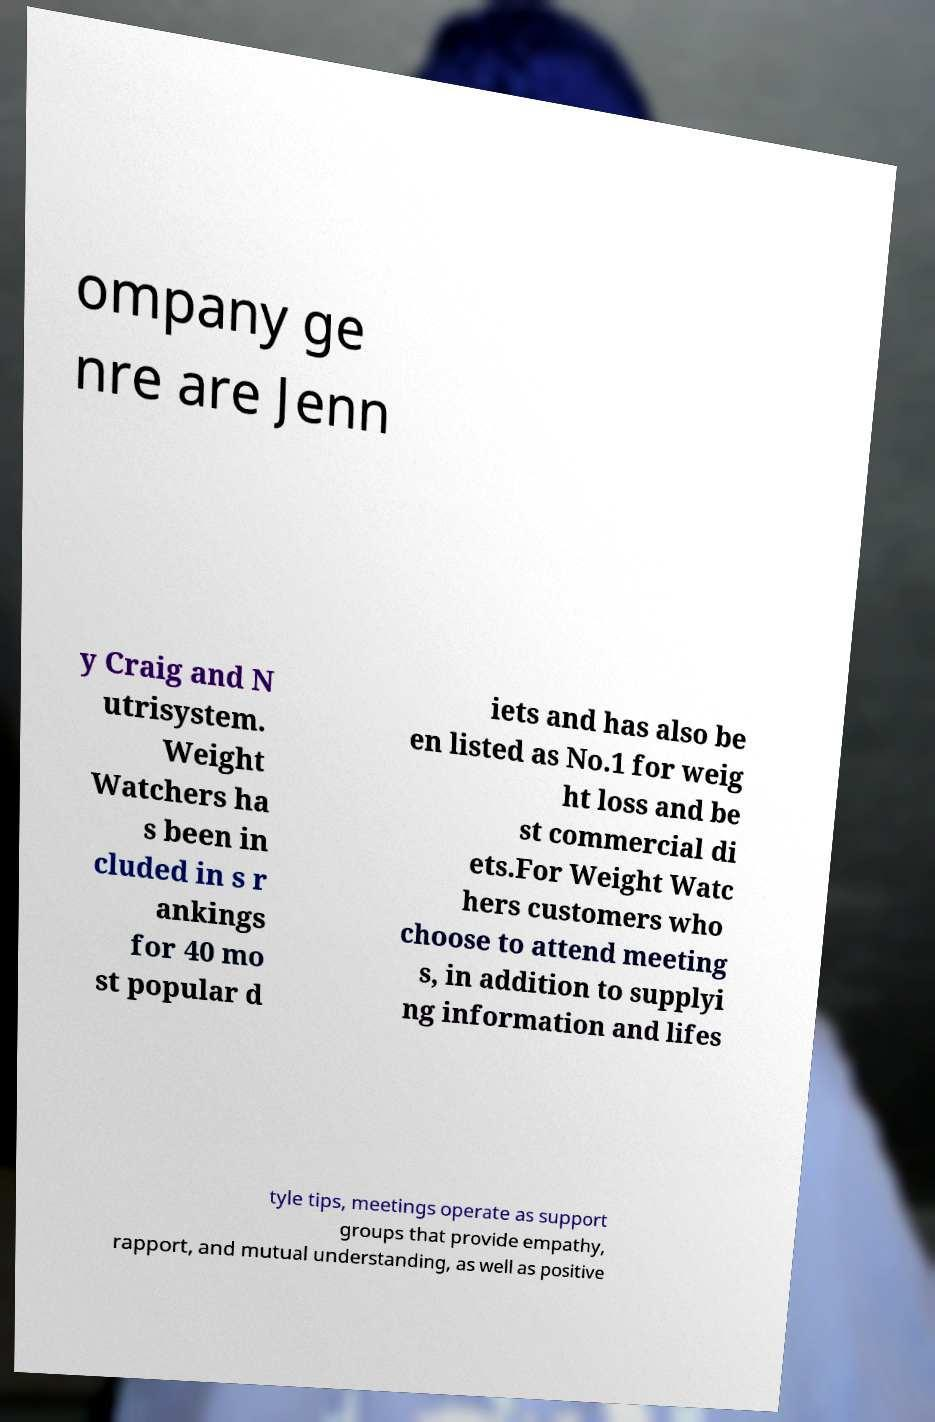Can you read and provide the text displayed in the image?This photo seems to have some interesting text. Can you extract and type it out for me? ompany ge nre are Jenn y Craig and N utrisystem. Weight Watchers ha s been in cluded in s r ankings for 40 mo st popular d iets and has also be en listed as No.1 for weig ht loss and be st commercial di ets.For Weight Watc hers customers who choose to attend meeting s, in addition to supplyi ng information and lifes tyle tips, meetings operate as support groups that provide empathy, rapport, and mutual understanding, as well as positive 